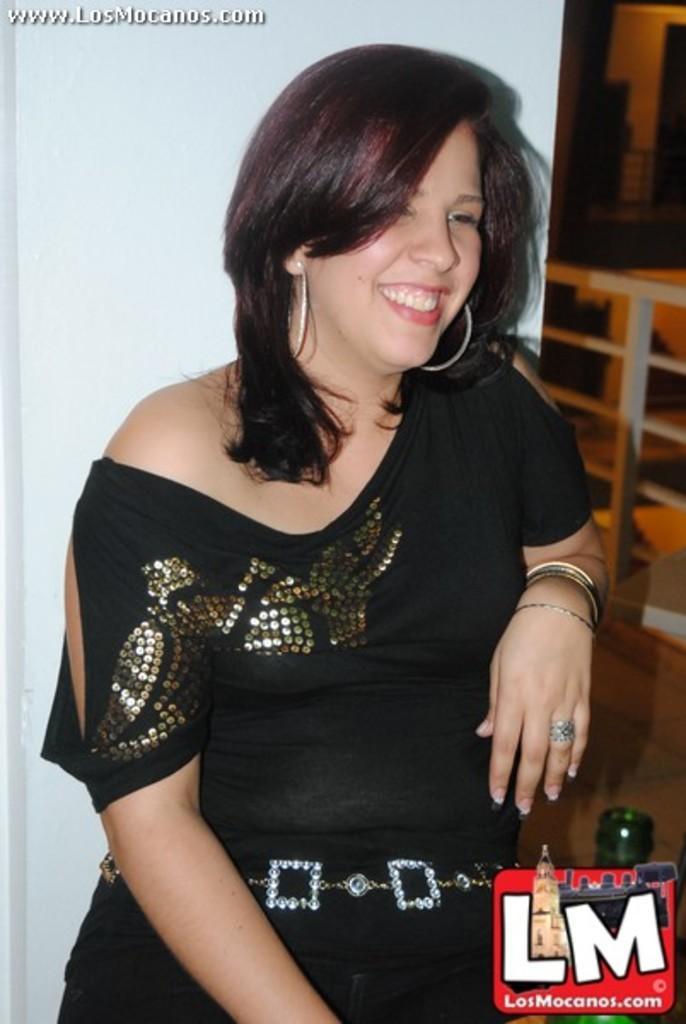In one or two sentences, can you explain what this image depicts? Here we can see a woman and she is smiling. There is a bottle and a logo. There is a white background. 